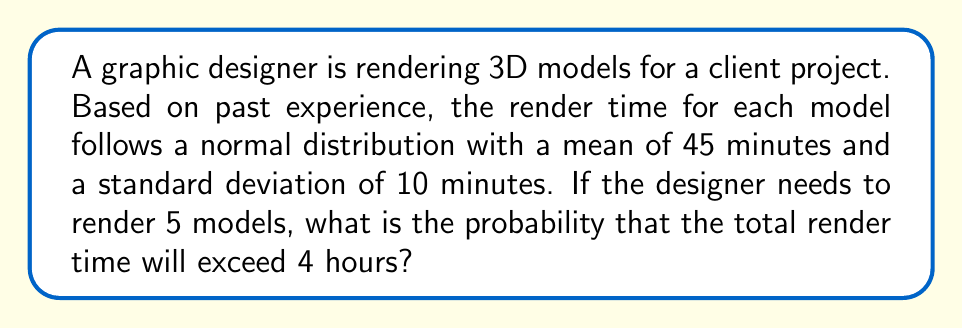Can you solve this math problem? Let's approach this step-by-step:

1) First, we need to convert 4 hours to minutes: 4 * 60 = 240 minutes

2) The total render time for 5 models will also follow a normal distribution. We need to calculate its mean and standard deviation:

   Mean: $\mu_{total} = 5 * 45 = 225$ minutes
   Standard deviation: $\sigma_{total} = \sqrt{5} * 10 = \sqrt{500} \approx 22.36$ minutes

3) We want to find $P(X > 240)$ where X is the total render time.

4) To standardize this, we calculate the z-score:

   $z = \frac{x - \mu}{\sigma} = \frac{240 - 225}{22.36} \approx 0.67$

5) We need to find $P(Z > 0.67)$, which is equal to $1 - P(Z < 0.67)$

6) Using a standard normal distribution table or calculator:

   $P(Z < 0.67) \approx 0.7486$

7) Therefore, $P(Z > 0.67) = 1 - 0.7486 = 0.2514$

Thus, the probability that the total render time will exceed 4 hours is approximately 0.2514 or 25.14%.
Answer: $0.2514$ or $25.14\%$ 